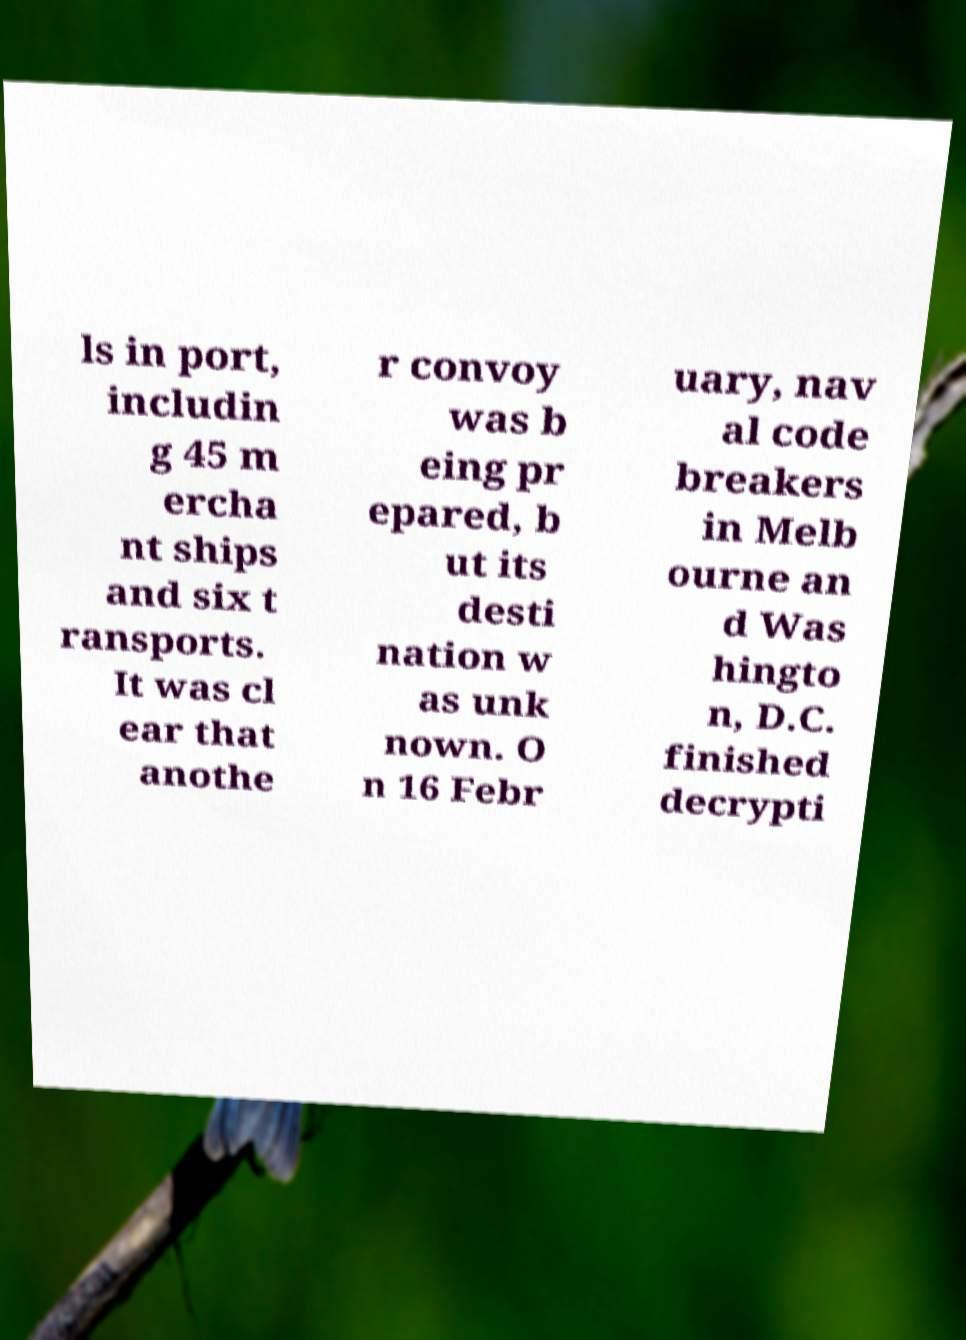Please read and relay the text visible in this image. What does it say? ls in port, includin g 45 m ercha nt ships and six t ransports. It was cl ear that anothe r convoy was b eing pr epared, b ut its desti nation w as unk nown. O n 16 Febr uary, nav al code breakers in Melb ourne an d Was hingto n, D.C. finished decrypti 